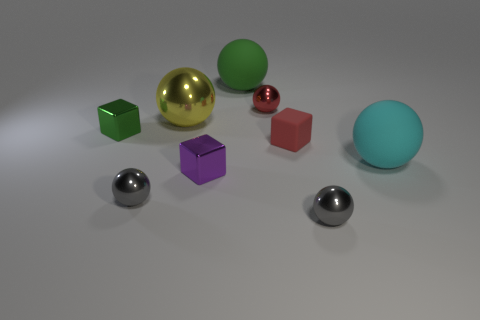Subtract 4 balls. How many balls are left? 2 Subtract all big green matte balls. How many balls are left? 5 Subtract all red spheres. How many spheres are left? 5 Subtract all red spheres. Subtract all purple cylinders. How many spheres are left? 5 Add 1 tiny yellow metallic spheres. How many objects exist? 10 Subtract all balls. How many objects are left? 3 Subtract 1 green spheres. How many objects are left? 8 Subtract all red things. Subtract all green rubber spheres. How many objects are left? 6 Add 5 large green spheres. How many large green spheres are left? 6 Add 2 tiny spheres. How many tiny spheres exist? 5 